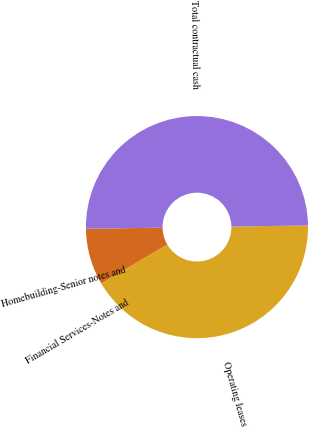<chart> <loc_0><loc_0><loc_500><loc_500><pie_chart><fcel>Homebuilding-Senior notes and<fcel>Financial Services-Notes and<fcel>Operating leases<fcel>Total contractual cash<nl><fcel>8.23%<fcel>0.02%<fcel>41.76%<fcel>50.0%<nl></chart> 